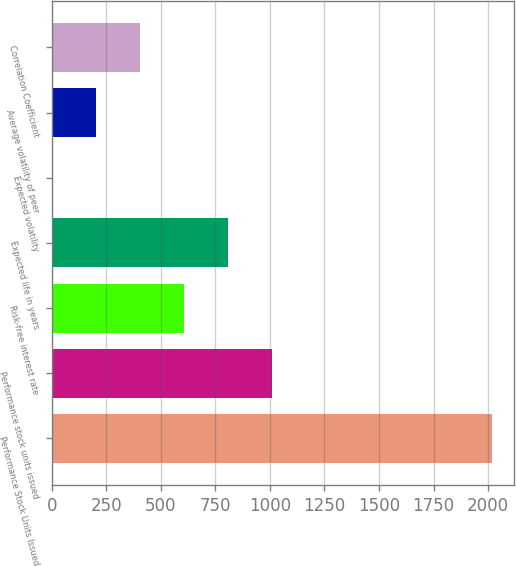Convert chart. <chart><loc_0><loc_0><loc_500><loc_500><bar_chart><fcel>Performance Stock Units Issued<fcel>Performance stock units issued<fcel>Risk-free interest rate<fcel>Expected life in years<fcel>Expected volatility<fcel>Average volatility of peer<fcel>Correlation Coefficient<nl><fcel>2017<fcel>1008.61<fcel>605.25<fcel>806.93<fcel>0.21<fcel>201.89<fcel>403.57<nl></chart> 